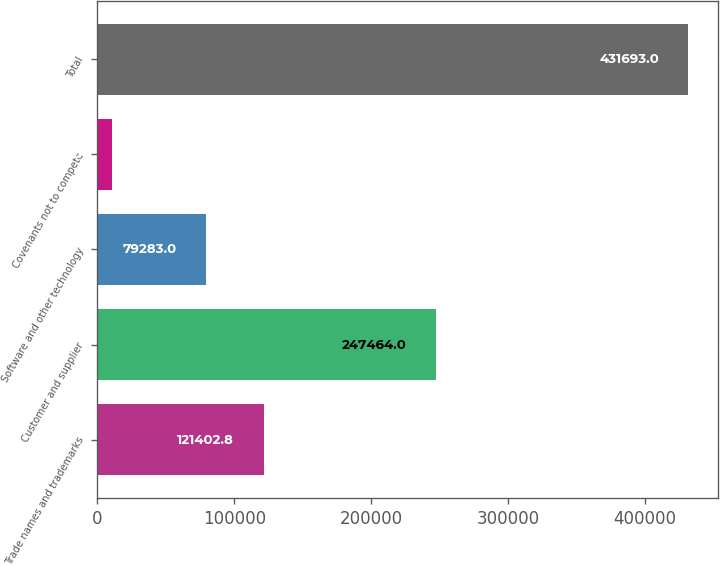<chart> <loc_0><loc_0><loc_500><loc_500><bar_chart><fcel>Trade names and trademarks<fcel>Customer and supplier<fcel>Software and other technology<fcel>Covenants not to compete<fcel>Total<nl><fcel>121403<fcel>247464<fcel>79283<fcel>10495<fcel>431693<nl></chart> 